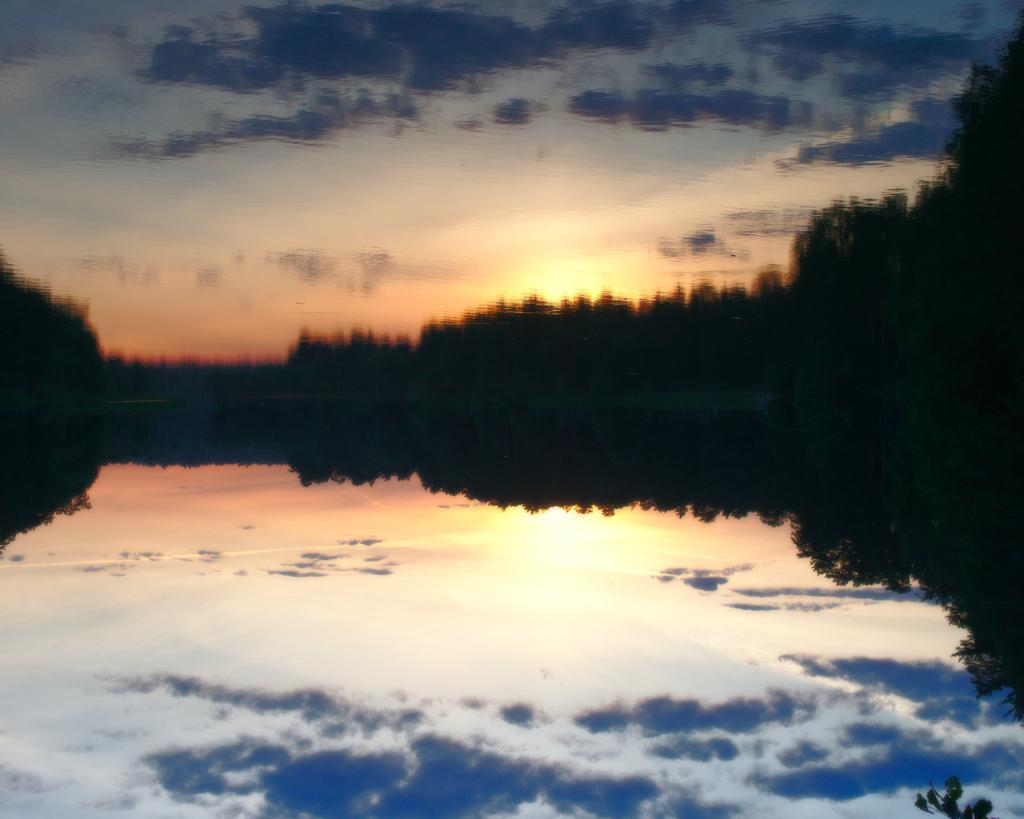What type of vegetation is visible in the foreground area of the image? There are trees in the foreground area of the image. What natural element is also present in the foreground area of the image? There is water in the foreground area of the image. What part of the natural environment is visible in the background of the image? The sky is visible in the background of the image. What type of insurance policy is being discussed in the image? There is no reference to any insurance policy in the image. How is the thumb being used in the image? There is no thumb present in the image. 